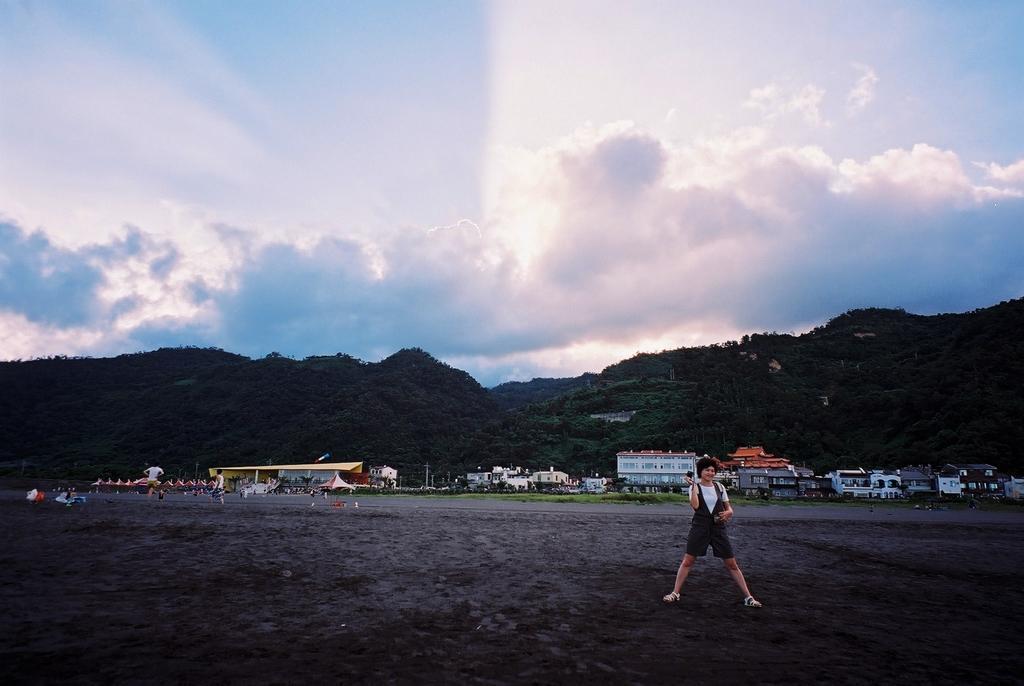Please provide a concise description of this image. In the picture we can see a woman standing on the ground surface and doing exercises and behind far away from her we can see houses, buildings, and behind it, we can see some hills covered with trees and behind it we can see the sky with clouds. 